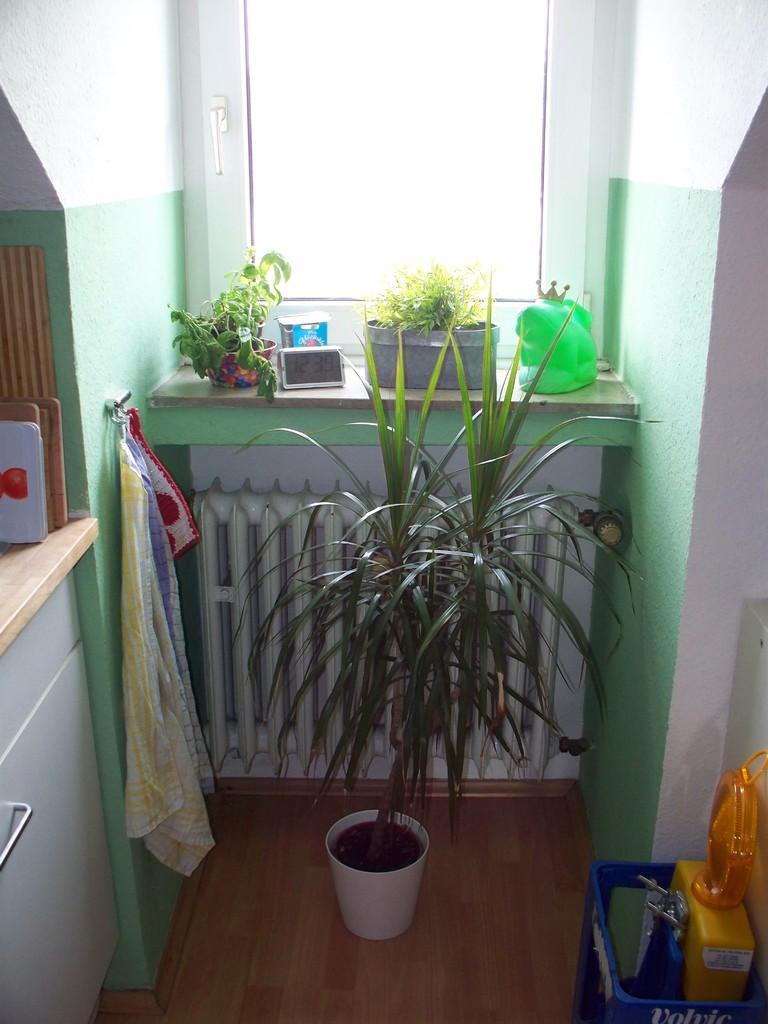Can you describe this image briefly? In this image we can see a table, here are the flower pots, here is the window, here is the cloth, here is the plant, here is the wall. 